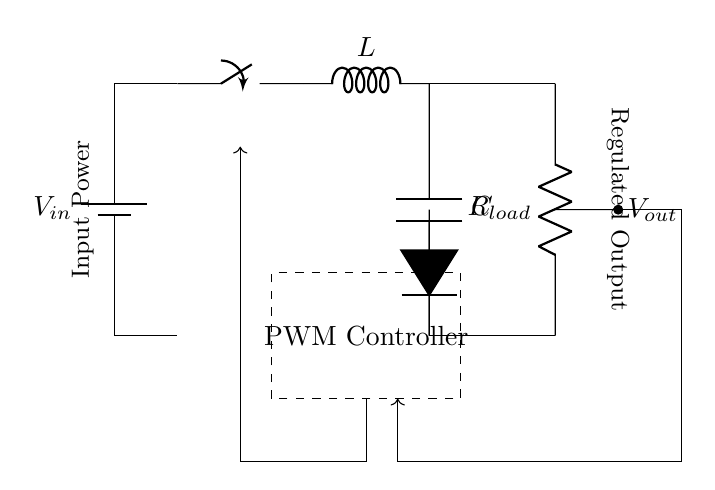What is the input component of the circuit? The input component is the battery, which provides the input voltage to the circuit.
Answer: Battery What type of controller is used in this circuit? The circuit uses a PWM (Pulse Width Modulation) controller, which adjusts the duty cycle to regulate output voltage.
Answer: PWM Controller What is the purpose of the inductor in the circuit? The inductor stores energy during the switch's on state and releases it to the load when the switch is off, helping to regulate the output voltage.
Answer: Energy storage What does the diode do in this circuit? The diode allows current to flow only in one direction, preventing the backflow of current to the inductor when the switch is open.
Answer: Prevents backflow How does the circuit achieve voltage regulation? The PWM controller adjusts the duty cycle of the switch to control the average voltage output, keeping it stable regardless of load changes.
Answer: Duty cycle adjustment What is the load component represented in the circuit? The load component is represented by a resistor, which consumes the output power delivered by the circuit.
Answer: Resistor What is the function of the capacitor in this circuit? The capacitor smooths out voltage fluctuations at the output by storing charge and providing it to the load when needed, stabilizing the output voltage.
Answer: Voltage smoothing 